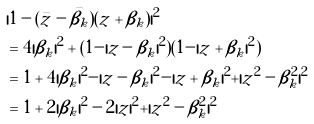<formula> <loc_0><loc_0><loc_500><loc_500>& | 1 - ( \bar { z } - \bar { \beta _ { k } } ) ( z + \beta _ { k } ) | ^ { 2 } \\ & = 4 | \beta _ { k } | ^ { 2 } + ( 1 - | z - \beta _ { k } | ^ { 2 } ) ( 1 - | z + \beta _ { k } | ^ { 2 } ) \\ & = 1 + 4 | \beta _ { k } | ^ { 2 } - | z - \beta _ { k } | ^ { 2 } - | z + \beta _ { k } | ^ { 2 } + | z ^ { 2 } - \beta _ { k } ^ { 2 } | ^ { 2 } \\ & = 1 + 2 | \beta _ { k } | ^ { 2 } - 2 | z | ^ { 2 } + | z ^ { 2 } - \beta _ { k } ^ { 2 } | ^ { 2 }</formula> 